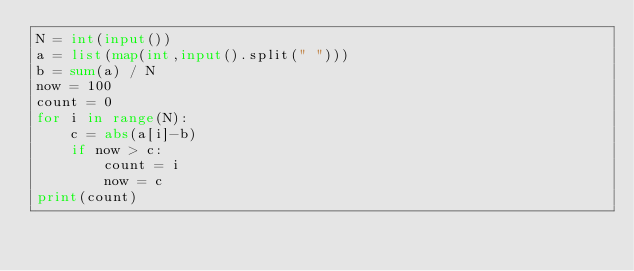Convert code to text. <code><loc_0><loc_0><loc_500><loc_500><_Python_>N = int(input())
a = list(map(int,input().split(" ")))
b = sum(a) / N
now = 100
count = 0
for i in range(N):
    c = abs(a[i]-b)
    if now > c:
        count = i
        now = c
print(count)
</code> 